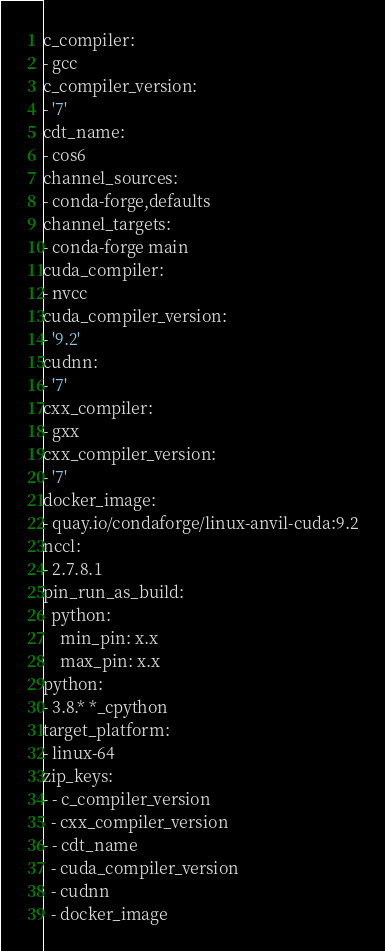<code> <loc_0><loc_0><loc_500><loc_500><_YAML_>c_compiler:
- gcc
c_compiler_version:
- '7'
cdt_name:
- cos6
channel_sources:
- conda-forge,defaults
channel_targets:
- conda-forge main
cuda_compiler:
- nvcc
cuda_compiler_version:
- '9.2'
cudnn:
- '7'
cxx_compiler:
- gxx
cxx_compiler_version:
- '7'
docker_image:
- quay.io/condaforge/linux-anvil-cuda:9.2
nccl:
- 2.7.8.1
pin_run_as_build:
  python:
    min_pin: x.x
    max_pin: x.x
python:
- 3.8.* *_cpython
target_platform:
- linux-64
zip_keys:
- - c_compiler_version
  - cxx_compiler_version
- - cdt_name
  - cuda_compiler_version
  - cudnn
  - docker_image
</code> 